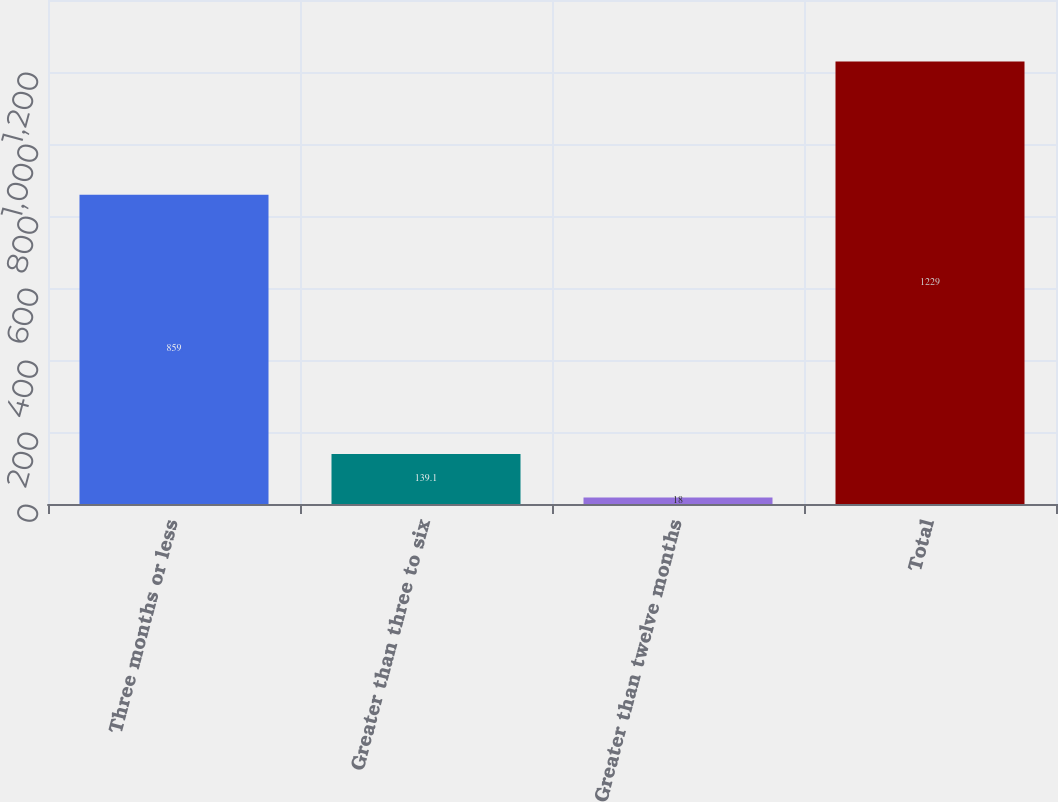Convert chart. <chart><loc_0><loc_0><loc_500><loc_500><bar_chart><fcel>Three months or less<fcel>Greater than three to six<fcel>Greater than twelve months<fcel>Total<nl><fcel>859<fcel>139.1<fcel>18<fcel>1229<nl></chart> 